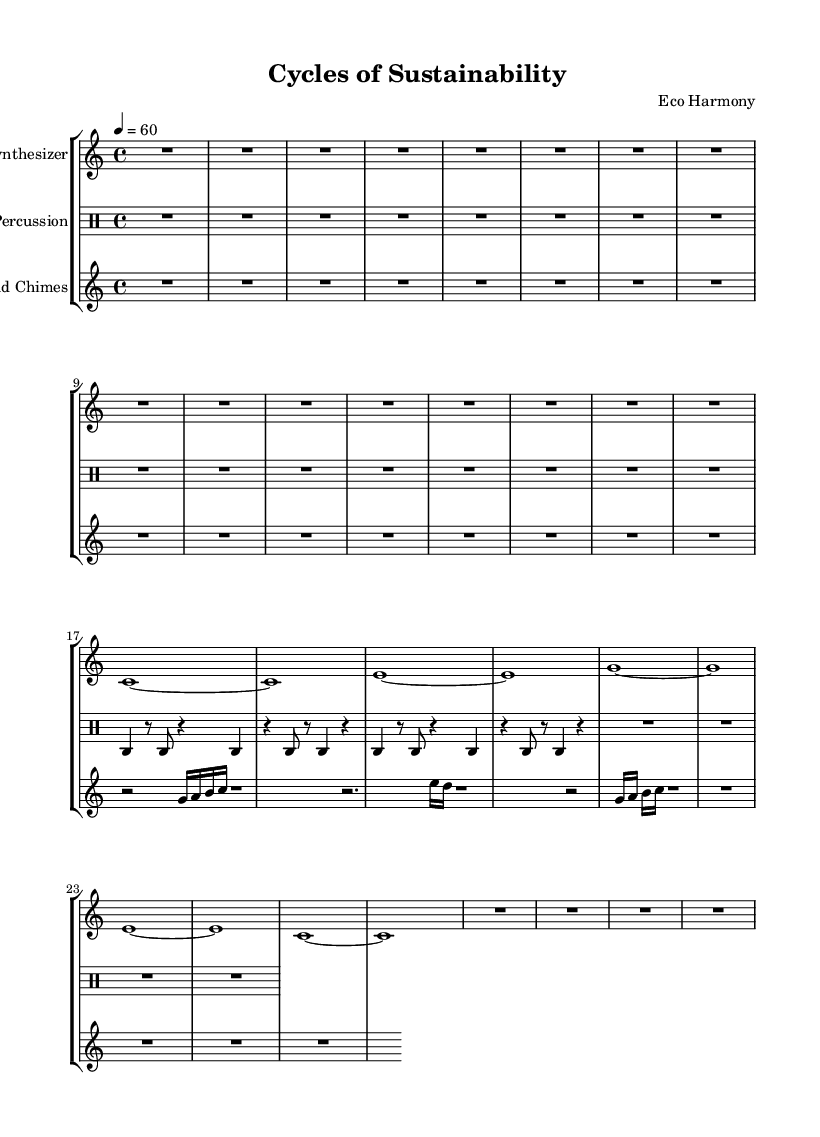What is the key signature of this music? The key signature is C major, which has no sharps or flats indicated. This can be determined by looking at the key signature symbol at the beginning of the score.
Answer: C major What is the time signature of this music? The time signature is 4/4, indicated at the beginning of the score. This tells you that there are four beats in a measure and the quarter note gets one beat.
Answer: 4/4 What is the tempo marking for this piece? The tempo marking is 60 beats per minute. The tempo is indicated at the beginning of the score stating "4 = 60," which indicates that the quarter note is to be played at 60 beats per minute.
Answer: 60 How many measures are in the synthesizer part? There are four measures in the synthesizer part. This can be determined by counting the distinct sets of vertical lines that represent the measures in the score.
Answer: 4 What type of musical texture is present in this piece? The musical texture is minimalist and drone-like, characterized by sustained notes that create a continuous sound. This can be inferred from the long-held notes and repetition throughout the synthesizer and wind chime parts.
Answer: Minimalist drone What role do the wind chimes play in this composition? The wind chimes contribute to the textural atmosphere of the piece by providing a light, ethereal sound that contrasts with the synthesizer's sustained tones. Their part features shorter notes emphasizing different rhythmic patterns.
Answer: Textural atmosphere How is the percussion part structured in terms of rhythm? The percussion part features a mix of rests and notes, with a steady pulse created by alternating between played notes and silence. This contributes to a rhythmic foundation while allowing the other instruments to shine.
Answer: Steady pulse 